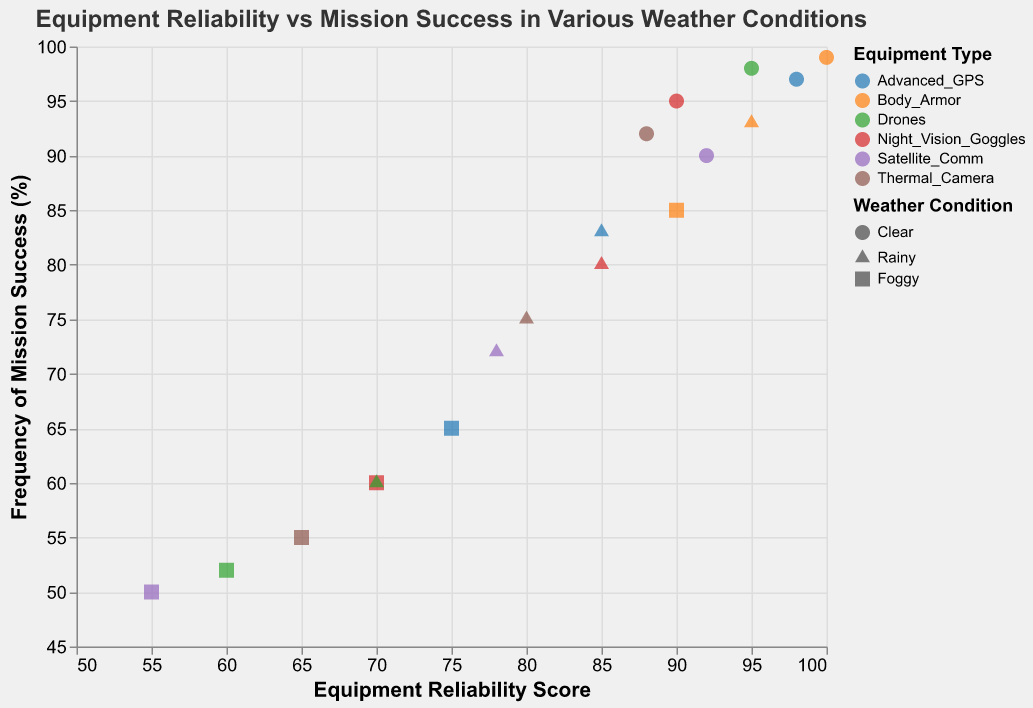How many data points are shown for Drones? The data contains entries for multiple pieces of equipment, with each piece having reliability scores under clear, rainy, and foggy conditions. As we focus on Drones, we count 3 data points corresponding to the three different weather conditions.
Answer: 3 Which piece of equipment has the highest frequency of mission success under clear conditions? By examining the plot, we find the data points for clear weather condition and identify that Body Armor has the highest frequency of mission success at 99%.
Answer: Body Armor What is the average equipment reliability score of Satellite_Comm in different weather conditions? Satellite_Comm has reliability scores of 92 (Clear), 78 (Rainy), and 55 (Foggy). The average is calculated as (92 + 78 + 55) / 3 = 75.
Answer: 75 Which equipment shows the lowest reliability score under foggy conditions? Checking all the data points labeled with Foggy weather, we identify that Satellite_Comm has the lowest reliability score at 55.
Answer: Satellite_Comm How does the frequency of mission success for Thermal_Camera under rainy conditions compare to that under foggy conditions? For Thermal_Camera, the frequency of mission success is 75 under rainy conditions and 55 under foggy conditions. This shows that the success rate drops by 20% from rainy to foggy.
Answer: Decreases by 20 What pattern can be observed between equipment reliability and mission success frequency for Advanced_GPS? By examining the three data points for Advanced_GPS, we see a pattern that as the reliability score decreases (Clear: 98, Rainy: 85, Foggy: 75), the frequency of mission success also decreases (Clear: 97, Rainy: 83, Foggy: 65).
Answer: Decreasing reliability corresponds to decreasing mission success frequency Identify the weather condition shapes and explain which shape represents rain. The plot uses different shapes for weather conditions: circles for Clear, triangles for Rainy, and squares for Foggy. According to this mapping, the shape representing rain is a triangle.
Answer: Triangle Find the difference in mission success frequency between clear and foggy conditions for Night_Vision_Goggles. For Night_Vision_Goggles, the frequency of mission success is 95 in clear conditions and 60 in foggy conditions. The difference is 95 - 60 = 35.
Answer: 35 